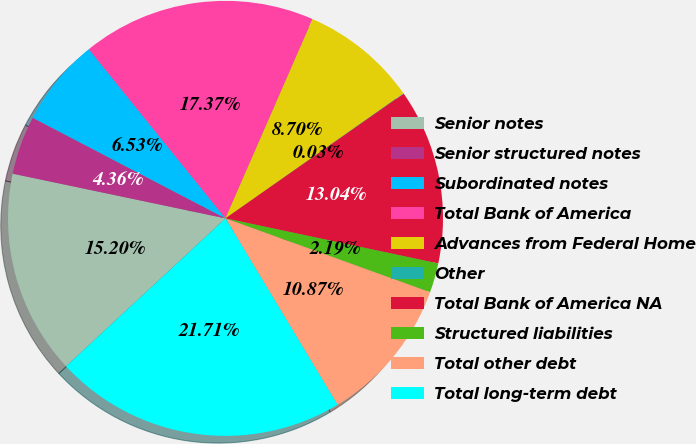Convert chart to OTSL. <chart><loc_0><loc_0><loc_500><loc_500><pie_chart><fcel>Senior notes<fcel>Senior structured notes<fcel>Subordinated notes<fcel>Total Bank of America<fcel>Advances from Federal Home<fcel>Other<fcel>Total Bank of America NA<fcel>Structured liabilities<fcel>Total other debt<fcel>Total long-term debt<nl><fcel>15.2%<fcel>4.36%<fcel>6.53%<fcel>17.37%<fcel>8.7%<fcel>0.03%<fcel>13.04%<fcel>2.19%<fcel>10.87%<fcel>21.71%<nl></chart> 